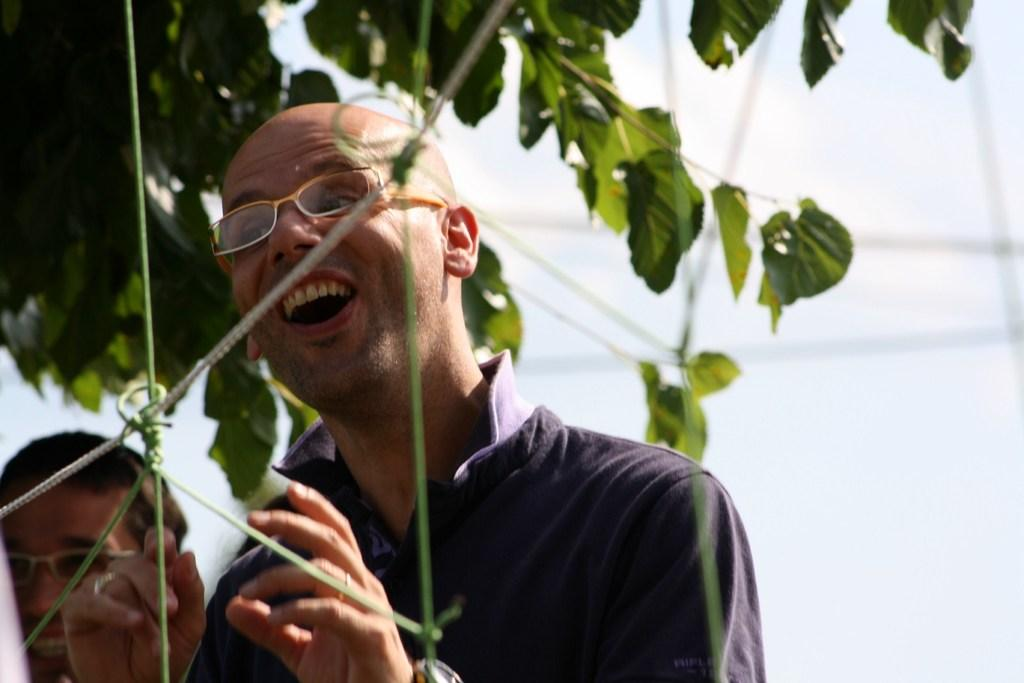How many people are in the image? There are two people in the image. What expressions do the people have on their faces? The people are wearing smiles on their faces. What can be seen in the background of the image? There is a tree visible in the background of the image. What position does the tree hold in the image? The tree is not holding a position in the image; it is a stationary object in the background. 